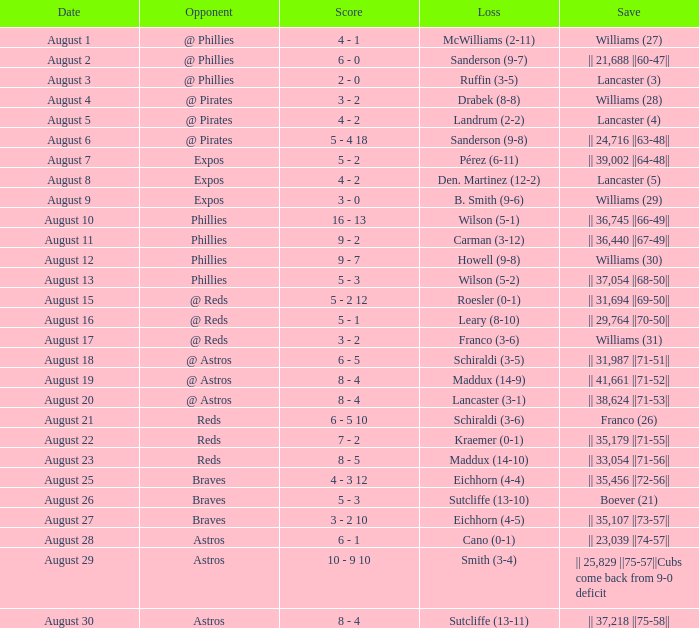Would you be able to parse every entry in this table? {'header': ['Date', 'Opponent', 'Score', 'Loss', 'Save'], 'rows': [['August 1', '@ Phillies', '4 - 1', 'McWilliams (2-11)', 'Williams (27)'], ['August 2', '@ Phillies', '6 - 0', 'Sanderson (9-7)', '|| 21,688 ||60-47||'], ['August 3', '@ Phillies', '2 - 0', 'Ruffin (3-5)', 'Lancaster (3)'], ['August 4', '@ Pirates', '3 - 2', 'Drabek (8-8)', 'Williams (28)'], ['August 5', '@ Pirates', '4 - 2', 'Landrum (2-2)', 'Lancaster (4)'], ['August 6', '@ Pirates', '5 - 4 18', 'Sanderson (9-8)', '|| 24,716 ||63-48||'], ['August 7', 'Expos', '5 - 2', 'Pérez (6-11)', '|| 39,002 ||64-48||'], ['August 8', 'Expos', '4 - 2', 'Den. Martinez (12-2)', 'Lancaster (5)'], ['August 9', 'Expos', '3 - 0', 'B. Smith (9-6)', 'Williams (29)'], ['August 10', 'Phillies', '16 - 13', 'Wilson (5-1)', '|| 36,745 ||66-49||'], ['August 11', 'Phillies', '9 - 2', 'Carman (3-12)', '|| 36,440 ||67-49||'], ['August 12', 'Phillies', '9 - 7', 'Howell (9-8)', 'Williams (30)'], ['August 13', 'Phillies', '5 - 3', 'Wilson (5-2)', '|| 37,054 ||68-50||'], ['August 15', '@ Reds', '5 - 2 12', 'Roesler (0-1)', '|| 31,694 ||69-50||'], ['August 16', '@ Reds', '5 - 1', 'Leary (8-10)', '|| 29,764 ||70-50||'], ['August 17', '@ Reds', '3 - 2', 'Franco (3-6)', 'Williams (31)'], ['August 18', '@ Astros', '6 - 5', 'Schiraldi (3-5)', '|| 31,987 ||71-51||'], ['August 19', '@ Astros', '8 - 4', 'Maddux (14-9)', '|| 41,661 ||71-52||'], ['August 20', '@ Astros', '8 - 4', 'Lancaster (3-1)', '|| 38,624 ||71-53||'], ['August 21', 'Reds', '6 - 5 10', 'Schiraldi (3-6)', 'Franco (26)'], ['August 22', 'Reds', '7 - 2', 'Kraemer (0-1)', '|| 35,179 ||71-55||'], ['August 23', 'Reds', '8 - 5', 'Maddux (14-10)', '|| 33,054 ||71-56||'], ['August 25', 'Braves', '4 - 3 12', 'Eichhorn (4-4)', '|| 35,456 ||72-56||'], ['August 26', 'Braves', '5 - 3', 'Sutcliffe (13-10)', 'Boever (21)'], ['August 27', 'Braves', '3 - 2 10', 'Eichhorn (4-5)', '|| 35,107 ||73-57||'], ['August 28', 'Astros', '6 - 1', 'Cano (0-1)', '|| 23,039 ||74-57||'], ['August 29', 'Astros', '10 - 9 10', 'Smith (3-4)', '|| 25,829 ||75-57||Cubs come back from 9-0 deficit'], ['August 30', 'Astros', '8 - 4', 'Sutcliffe (13-11)', '|| 37,218 ||75-58||']]} Identify the adversary who faced a loss against sanderson, with the score being 9-8. @ Pirates. 